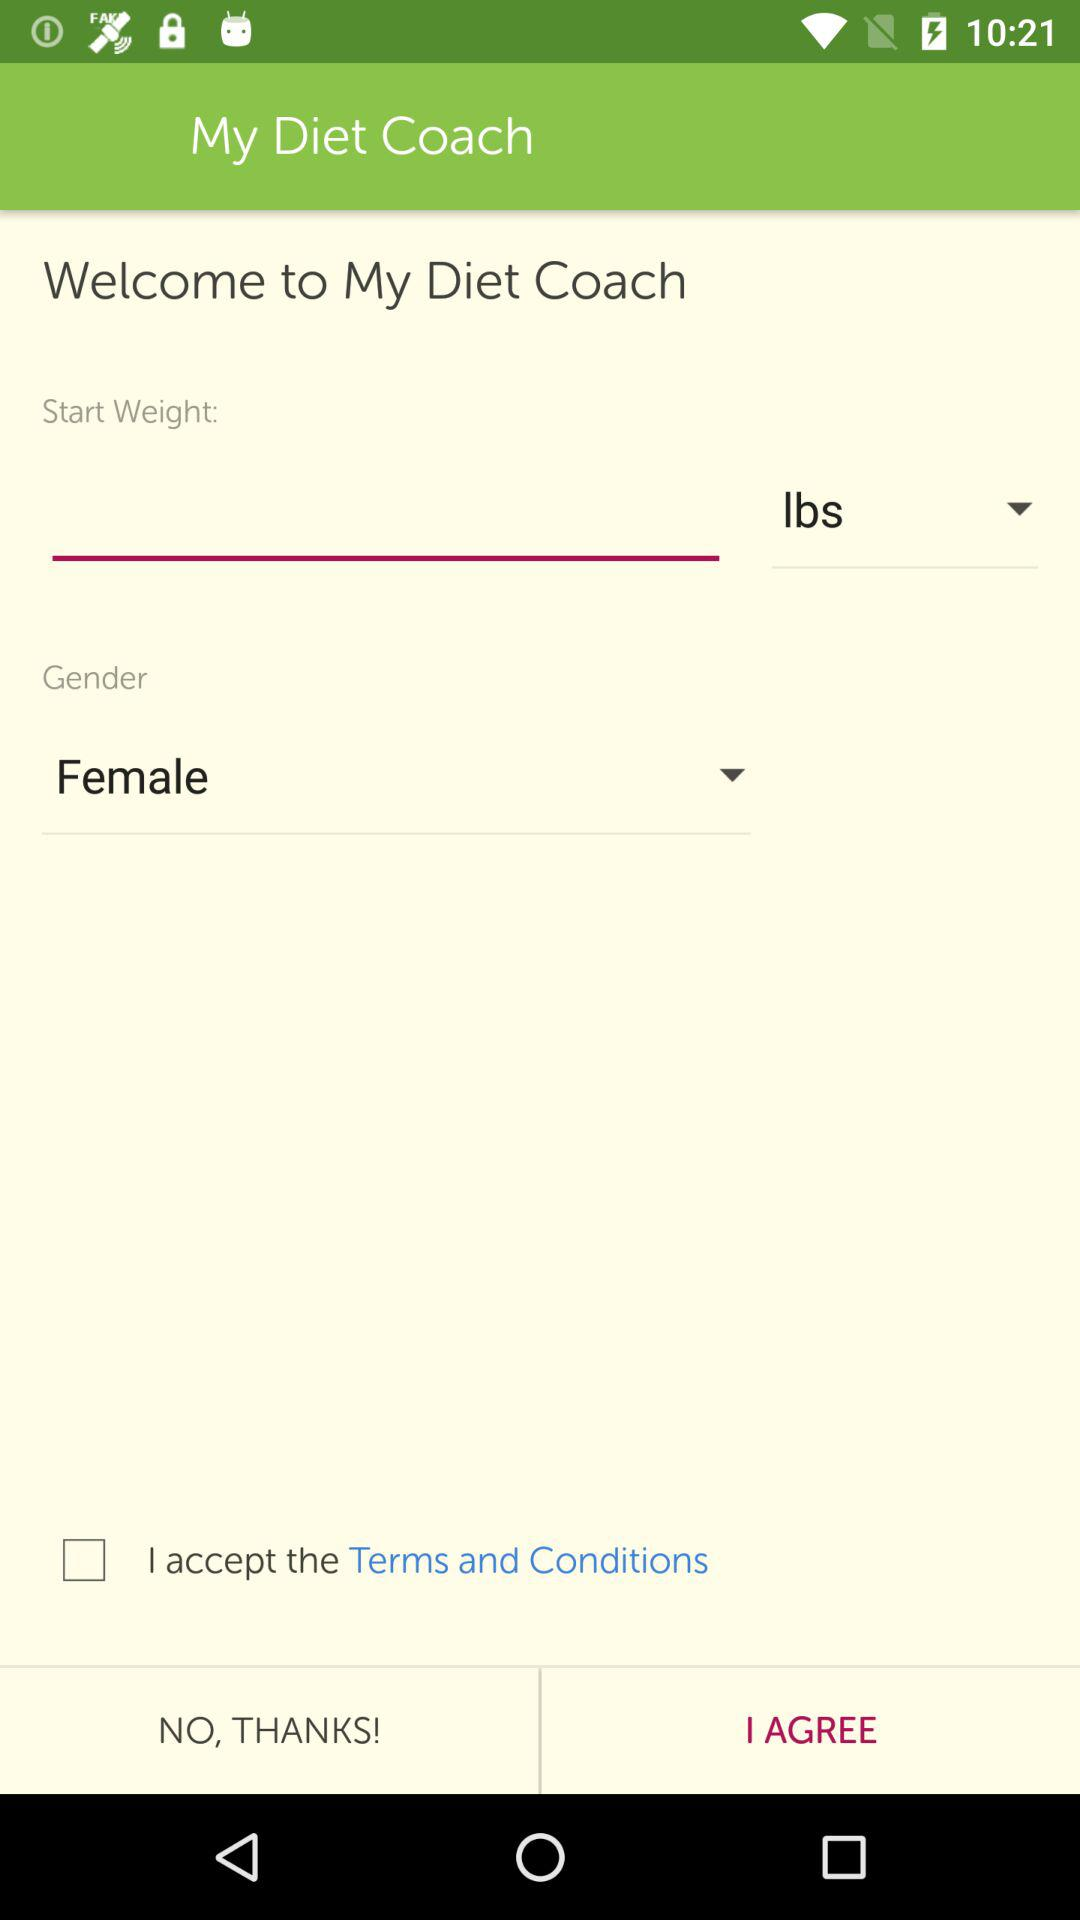Which unit is selected for weight? The selected unit is lbs. 